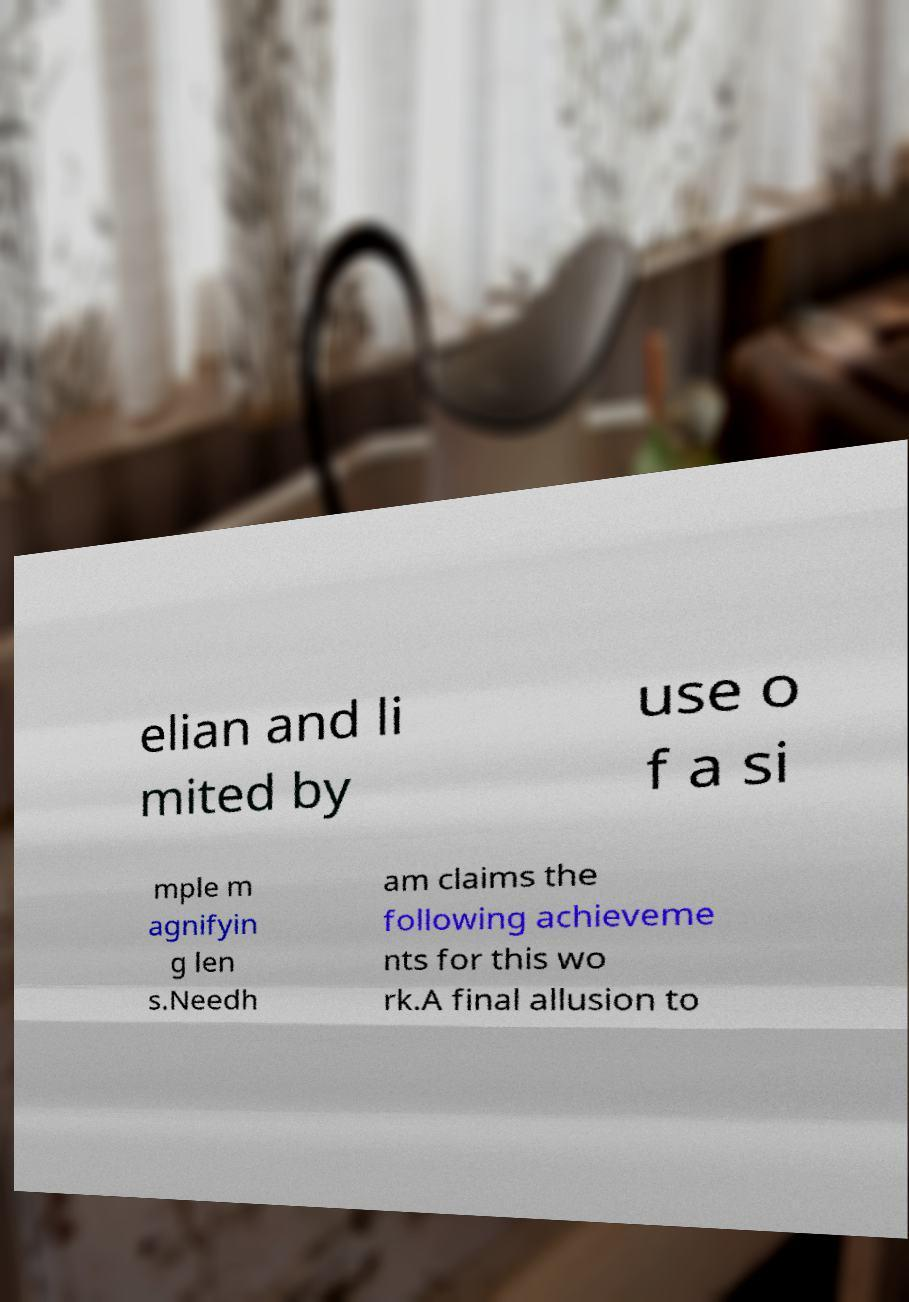I need the written content from this picture converted into text. Can you do that? elian and li mited by use o f a si mple m agnifyin g len s.Needh am claims the following achieveme nts for this wo rk.A final allusion to 